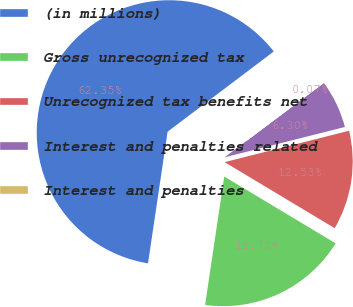<chart> <loc_0><loc_0><loc_500><loc_500><pie_chart><fcel>(in millions)<fcel>Gross unrecognized tax<fcel>Unrecognized tax benefits net<fcel>Interest and penalties related<fcel>Interest and penalties<nl><fcel>62.34%<fcel>18.75%<fcel>12.53%<fcel>6.3%<fcel>0.07%<nl></chart> 